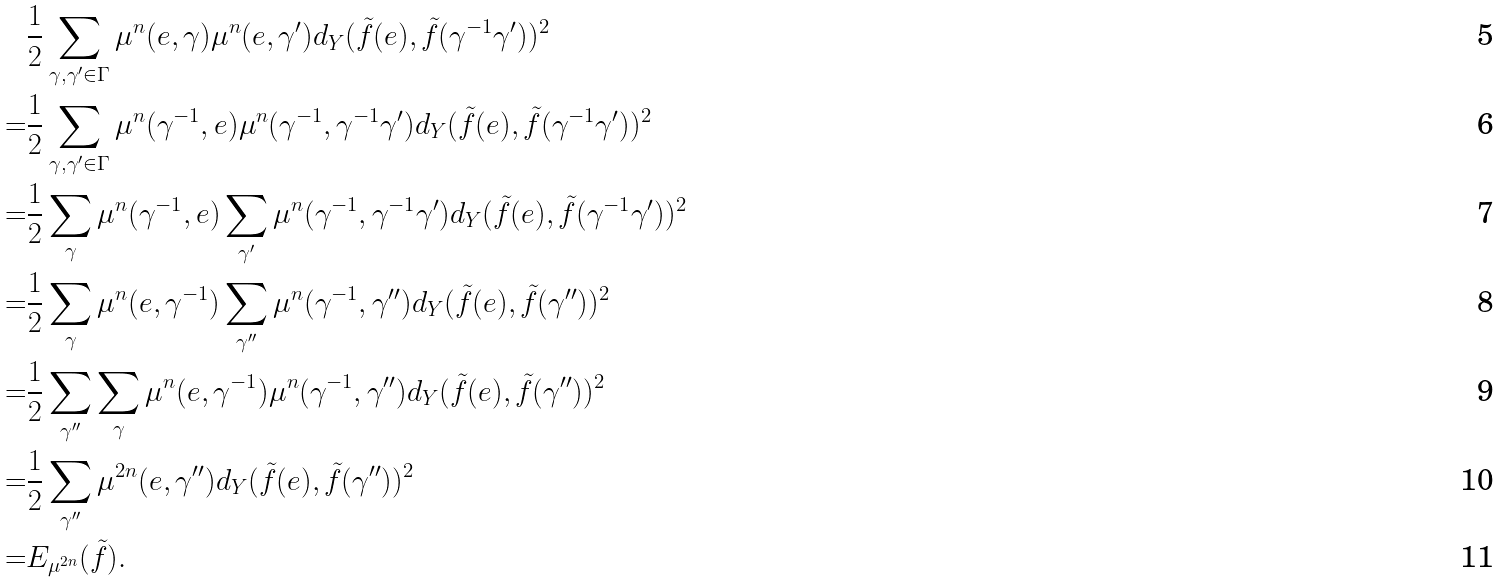Convert formula to latex. <formula><loc_0><loc_0><loc_500><loc_500>& \frac { 1 } { 2 } \sum _ { \gamma , \gamma ^ { \prime } \in \Gamma } \mu ^ { n } ( e , \gamma ) \mu ^ { n } ( e , \gamma ^ { \prime } ) d _ { Y } ( \tilde { f } ( e ) , \tilde { f } ( \gamma ^ { - 1 } \gamma ^ { \prime } ) ) ^ { 2 } \\ = & \frac { 1 } { 2 } \sum _ { \gamma , \gamma ^ { \prime } \in \Gamma } \mu ^ { n } ( \gamma ^ { - 1 } , e ) \mu ^ { n } ( \gamma ^ { - 1 } , \gamma ^ { - 1 } \gamma ^ { \prime } ) d _ { Y } ( \tilde { f } ( e ) , \tilde { f } ( \gamma ^ { - 1 } \gamma ^ { \prime } ) ) ^ { 2 } \\ = & \frac { 1 } { 2 } \sum _ { \gamma } \mu ^ { n } ( \gamma ^ { - 1 } , e ) \sum _ { \gamma ^ { \prime } } \mu ^ { n } ( \gamma ^ { - 1 } , \gamma ^ { - 1 } \gamma ^ { \prime } ) d _ { Y } ( \tilde { f } ( e ) , \tilde { f } ( \gamma ^ { - 1 } \gamma ^ { \prime } ) ) ^ { 2 } \\ = & \frac { 1 } { 2 } \sum _ { \gamma } \mu ^ { n } ( e , \gamma ^ { - 1 } ) \sum _ { \gamma ^ { \prime \prime } } \mu ^ { n } ( \gamma ^ { - 1 } , \gamma ^ { \prime \prime } ) d _ { Y } ( \tilde { f } ( e ) , \tilde { f } ( \gamma ^ { \prime \prime } ) ) ^ { 2 } \\ = & \frac { 1 } { 2 } \sum _ { \gamma ^ { \prime \prime } } \sum _ { \gamma } \mu ^ { n } ( e , \gamma ^ { - 1 } ) \mu ^ { n } ( \gamma ^ { - 1 } , \gamma ^ { \prime \prime } ) d _ { Y } ( \tilde { f } ( e ) , \tilde { f } ( \gamma ^ { \prime \prime } ) ) ^ { 2 } \\ = & \frac { 1 } { 2 } \sum _ { \gamma ^ { \prime \prime } } \mu ^ { 2 n } ( e , \gamma ^ { \prime \prime } ) d _ { Y } ( \tilde { f } ( e ) , \tilde { f } ( \gamma ^ { \prime \prime } ) ) ^ { 2 } \\ = & E _ { \mu ^ { 2 n } } ( \tilde { f } ) .</formula> 